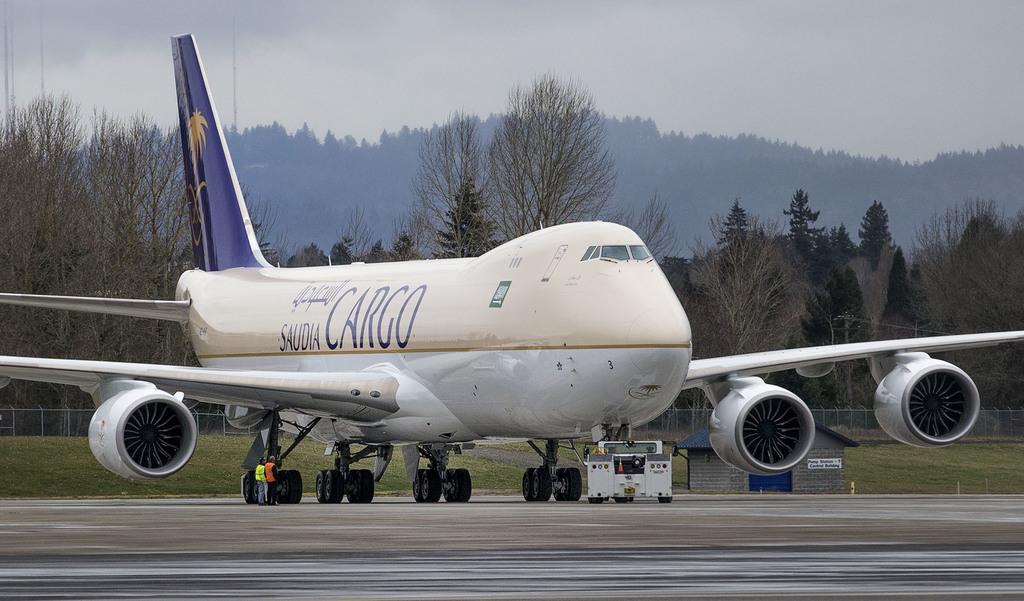What type of plane is this?
Your answer should be compact. Cargo. 